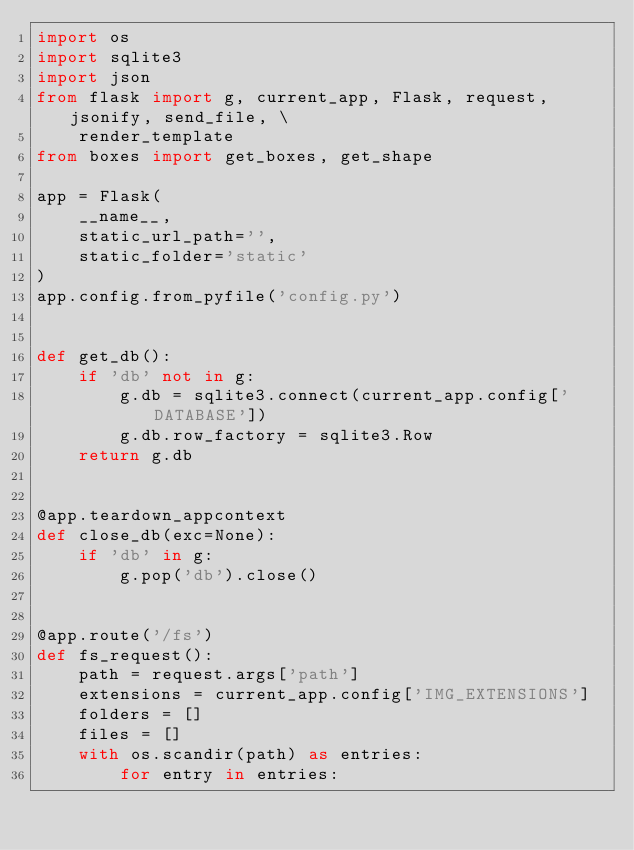<code> <loc_0><loc_0><loc_500><loc_500><_Python_>import os
import sqlite3
import json
from flask import g, current_app, Flask, request, jsonify, send_file, \
    render_template
from boxes import get_boxes, get_shape

app = Flask(
    __name__,
    static_url_path='',
    static_folder='static'
)
app.config.from_pyfile('config.py')


def get_db():
    if 'db' not in g:
        g.db = sqlite3.connect(current_app.config['DATABASE'])
        g.db.row_factory = sqlite3.Row
    return g.db


@app.teardown_appcontext
def close_db(exc=None):
    if 'db' in g:
        g.pop('db').close()


@app.route('/fs')
def fs_request():
    path = request.args['path']
    extensions = current_app.config['IMG_EXTENSIONS']
    folders = []
    files = []
    with os.scandir(path) as entries:
        for entry in entries:</code> 